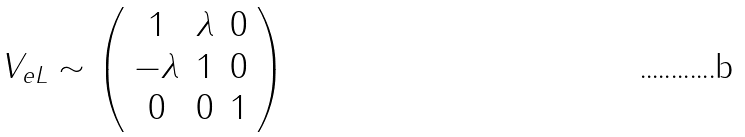Convert formula to latex. <formula><loc_0><loc_0><loc_500><loc_500>V _ { e L } \sim \left ( \begin{array} { c c c } 1 & \lambda & 0 \\ - \lambda & 1 & 0 \\ 0 & 0 & 1 \end{array} \right )</formula> 